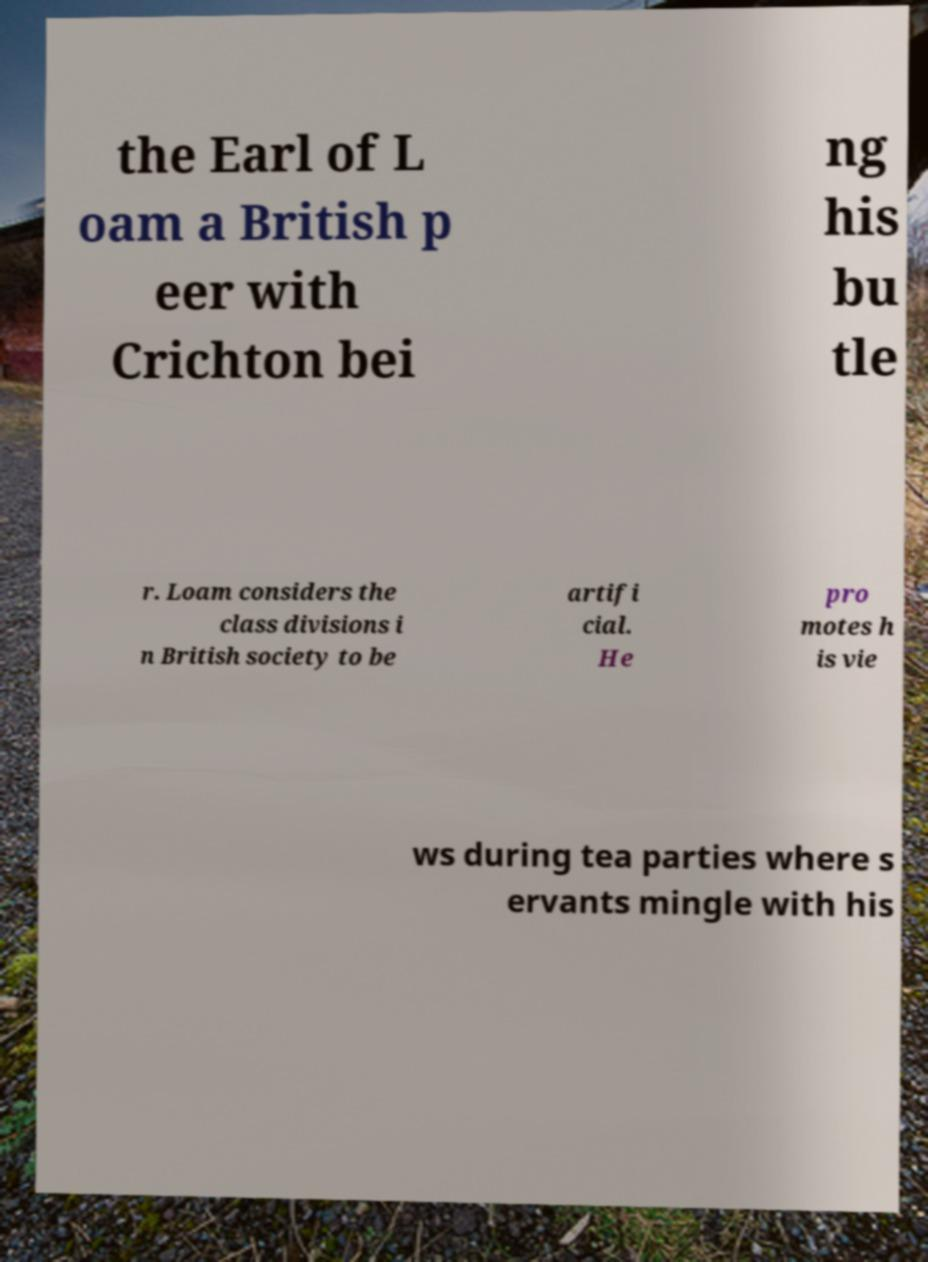Please read and relay the text visible in this image. What does it say? the Earl of L oam a British p eer with Crichton bei ng his bu tle r. Loam considers the class divisions i n British society to be artifi cial. He pro motes h is vie ws during tea parties where s ervants mingle with his 